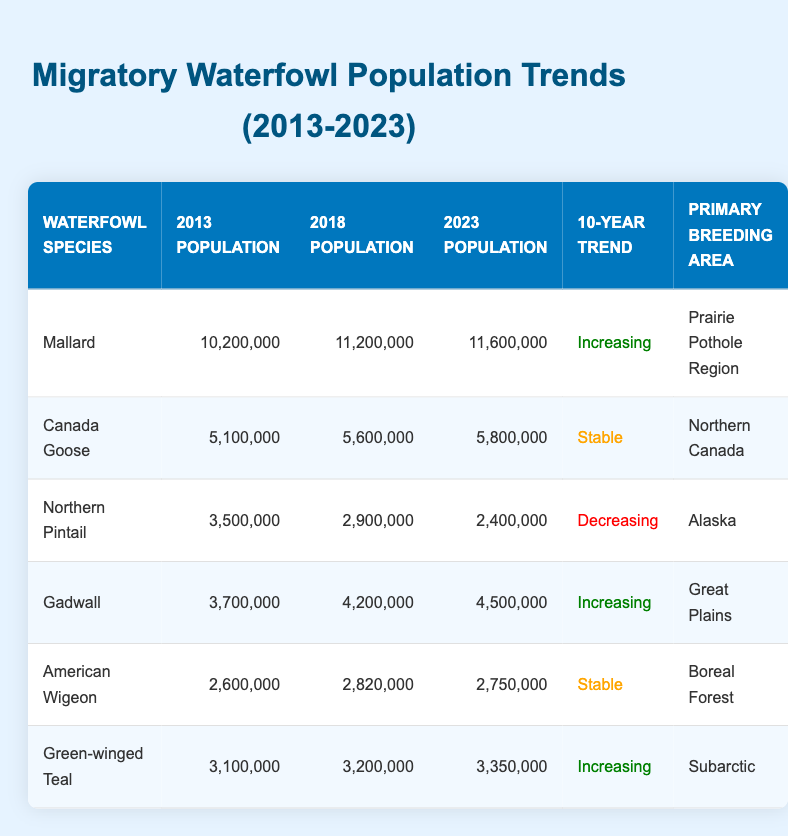What was the population of Mallard in 2018? The table shows that the population of Mallard in 2018 was 11,200,000.
Answer: 11,200,000 Which waterfowl species has a decreasing population trend? The table indicates that the Northern Pintail has a decreasing population trend, as its population declined from 3,500,000 in 2013 to 2,400,000 in 2023.
Answer: Northern Pintail What is the total population of Gadwall and Green-winged Teal in 2023? To find this, we need the 2023 population of Gadwall (4,500,000) and Green-winged Teal (3,350,000). Adding these values gives 4,500,000 + 3,350,000 = 7,850,000.
Answer: 7,850,000 Did the American Wigeon experience a population increase over the decade? No, the American Wigeon had populations of 2,600,000 in 2013, 2,820,000 in 2018, and decreased to 2,750,000 in 2023, indicating a decline over the decade.
Answer: No Which species had the highest population in 2023 and what was that population? The table reveals that the Mallard had the highest population in 2023, with a total of 11,600,000.
Answer: Mallard, 11,600,000 What is the average population of the Canada Goose over the three years recorded? The Canada Goose population in 2013 was 5,100,000, in 2018 it was 5,600,000, and in 2023 it was 5,800,000. To calculate the average: (5,100,000 + 5,600,000 + 5,800,000) / 3 = 5,500,000.
Answer: 5,500,000 How many species have a stable population trend? The table shows that there are three species with a stable population trend: Canada Goose, American Wigeon, and Northern Pintail.
Answer: 3 What was the population change for Northern Pintail from 2013 to 2023? The Northern Pintail had a population of 3,500,000 in 2013 and decreased to 2,400,000 in 2023. To find the change: 3,500,000 - 2,400,000 = 1,100,000 (a decrease).
Answer: Decrease of 1,100,000 Which species has the largest population increase over the decade? The table shows that the Mallard had an increase from 10,200,000 to 11,600,000, an increase of 1,400,000, which is higher than other species.
Answer: Mallard 